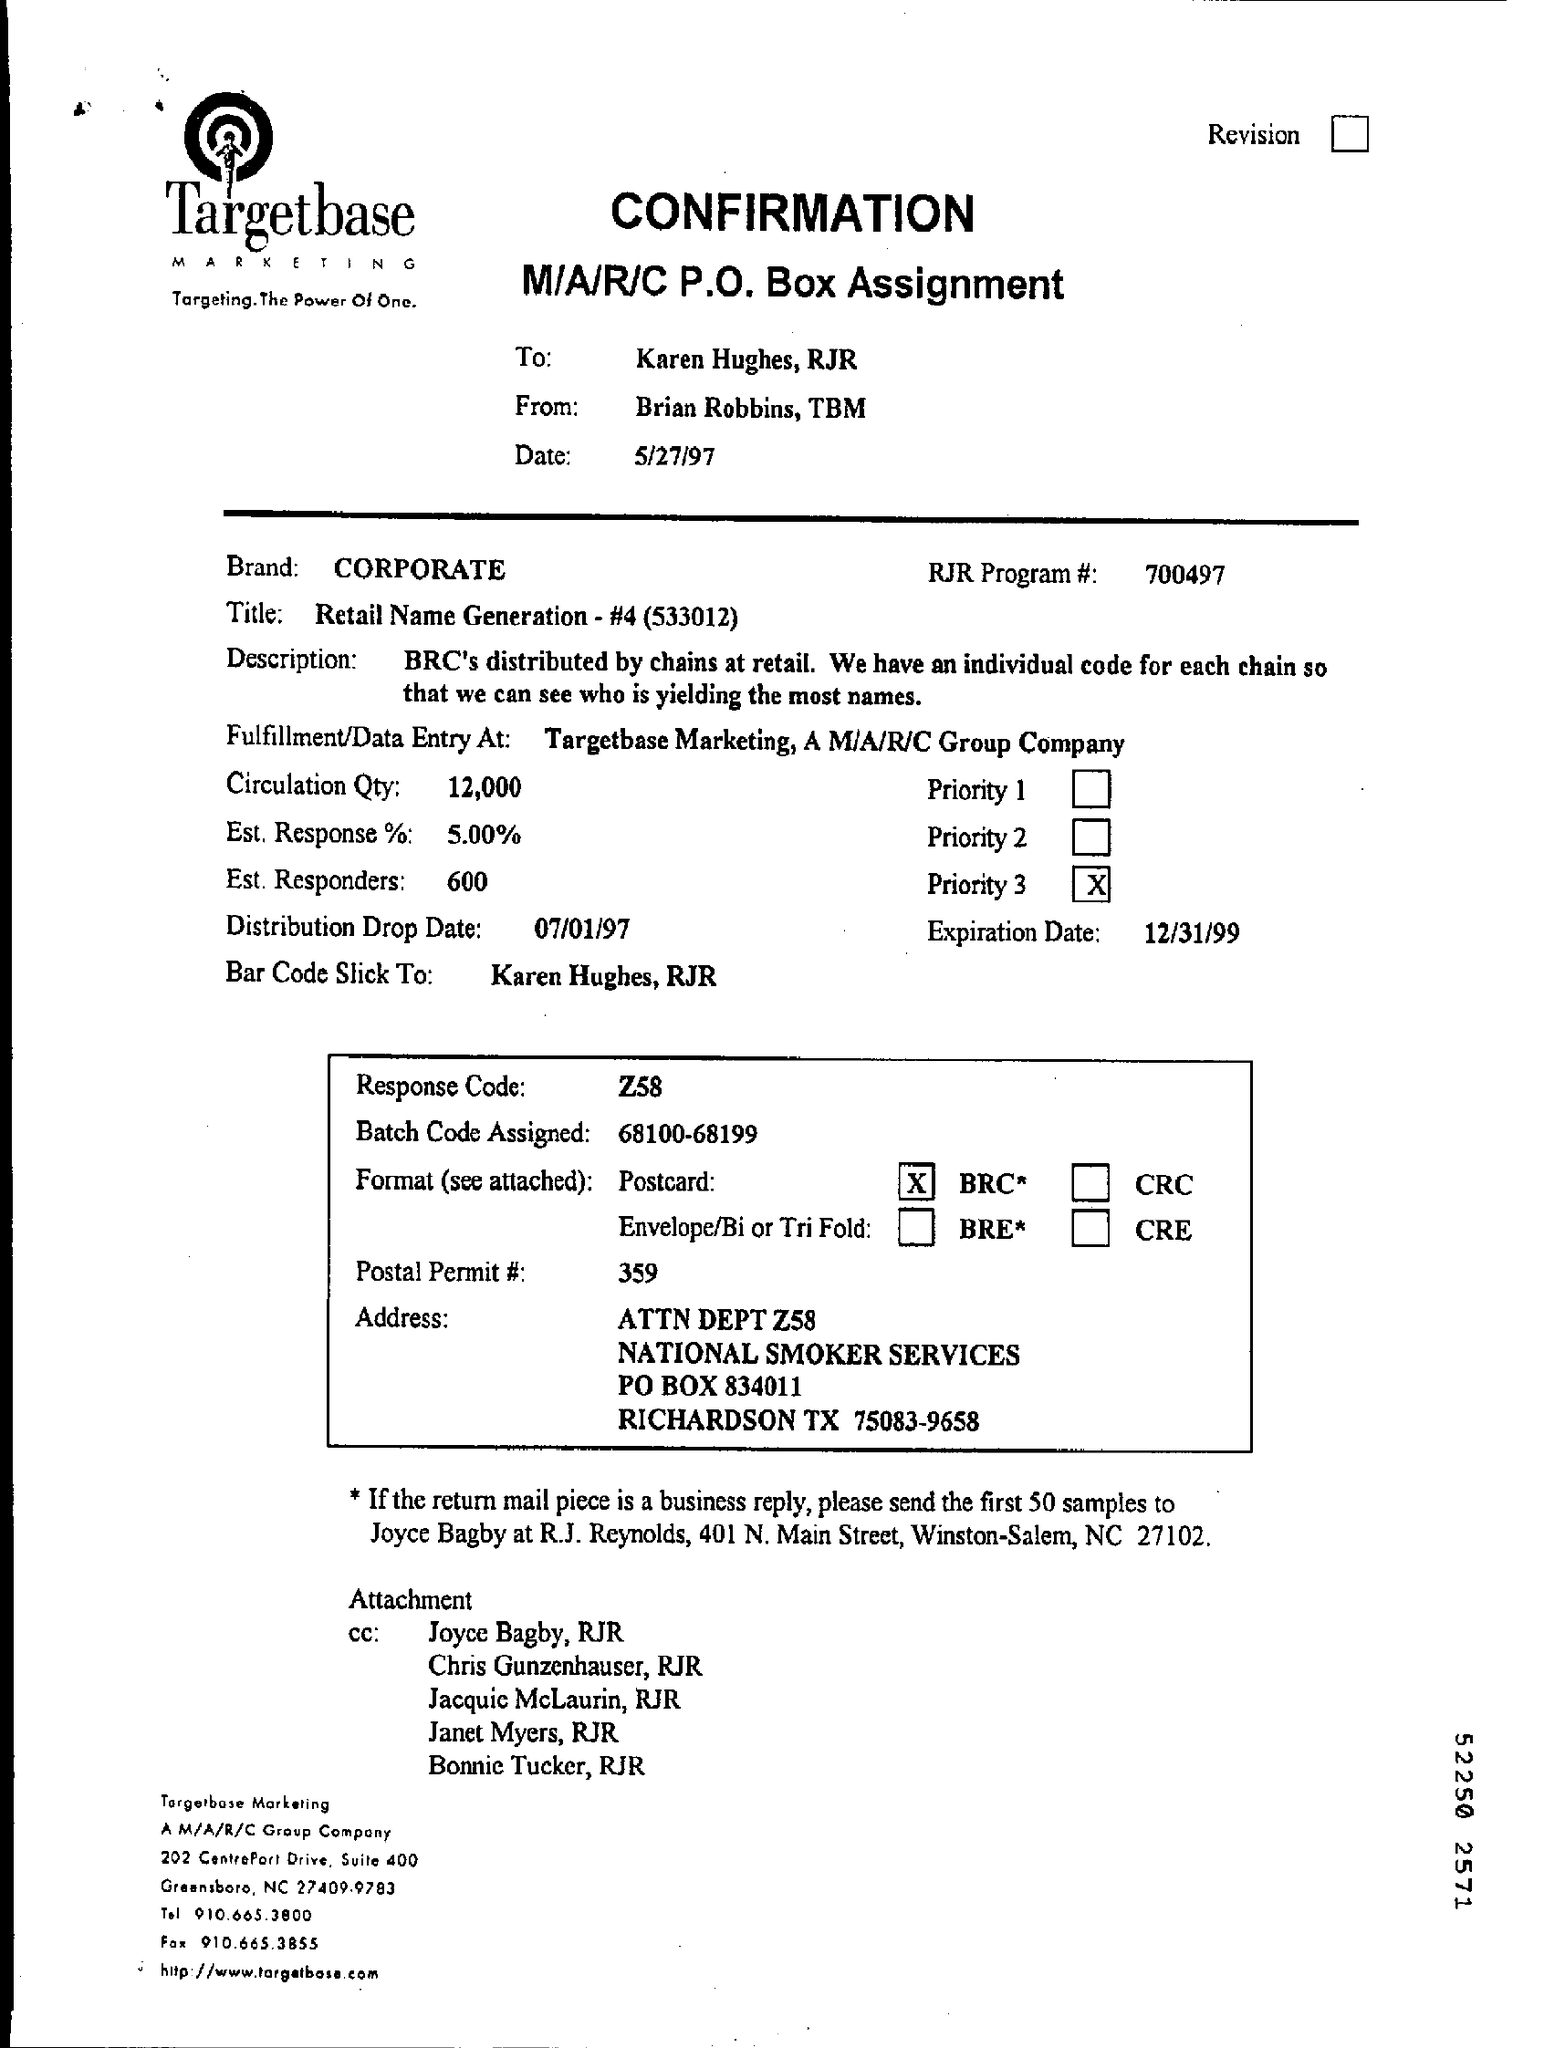Indicate a few pertinent items in this graphic. The response code is Z58. The circulation quantity is 12,000. The EST response is approximately 5.00%. The question is asking for the number 359. 